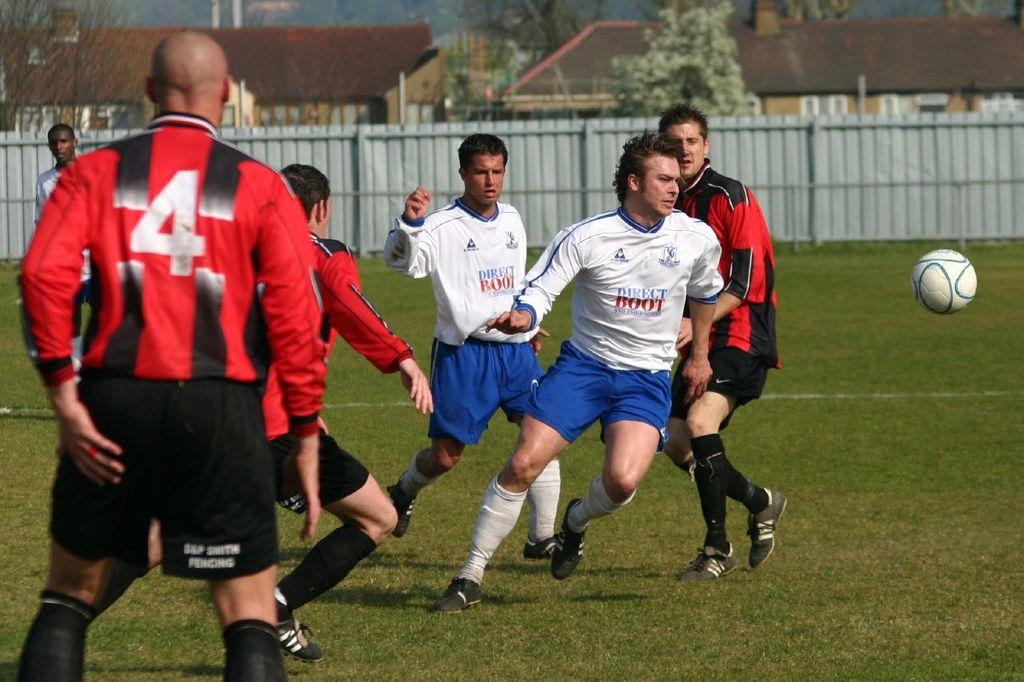<image>
Provide a brief description of the given image. A player with "Direct Boot" on his shirt moves toward the soccer ball near him. 